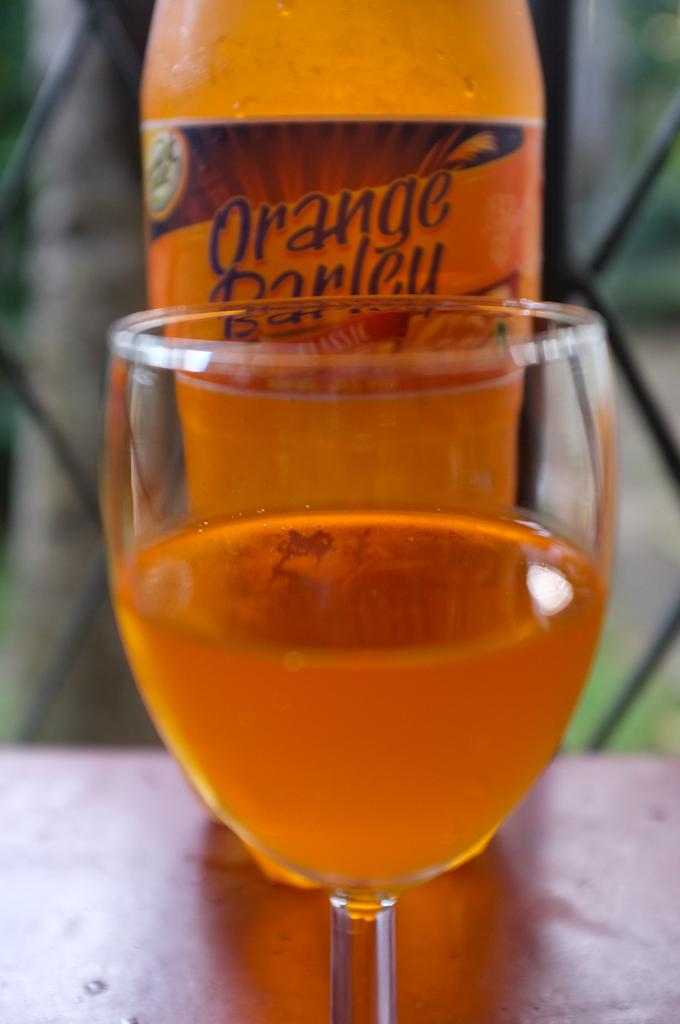<image>
Relay a brief, clear account of the picture shown. A glass and a bottle of orange barley are on the table. 